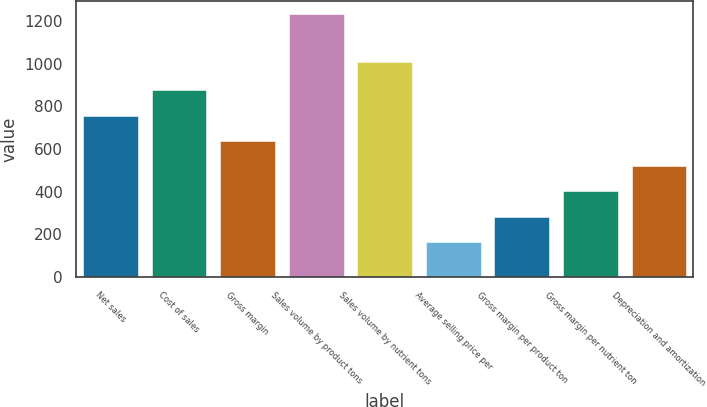<chart> <loc_0><loc_0><loc_500><loc_500><bar_chart><fcel>Net sales<fcel>Cost of sales<fcel>Gross margin<fcel>Sales volume by product tons<fcel>Sales volume by nutrient tons<fcel>Average selling price per<fcel>Gross margin per product ton<fcel>Gross margin per nutrient ton<fcel>Depreciation and amortization<nl><fcel>757<fcel>875.5<fcel>638.5<fcel>1231<fcel>1009<fcel>164.5<fcel>283<fcel>401.5<fcel>520<nl></chart> 